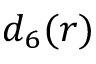<formula> <loc_0><loc_0><loc_500><loc_500>d _ { 6 } ( r )</formula> 